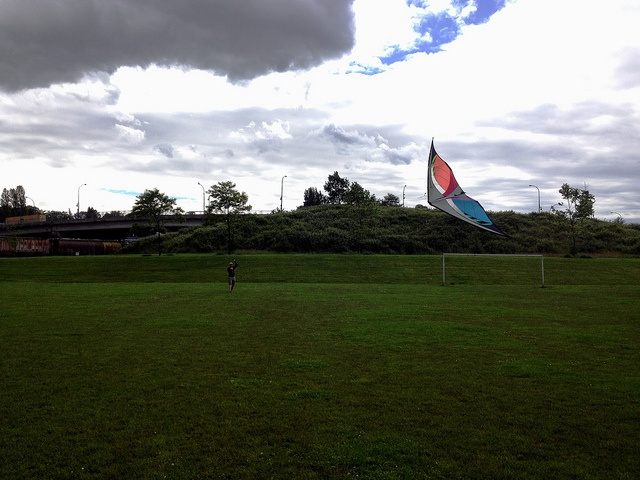Describe the objects in this image and their specific colors. I can see kite in darkgray, gray, black, teal, and salmon tones, truck in darkgray, black, maroon, and gray tones, and people in darkgray, black, gray, and darkgreen tones in this image. 